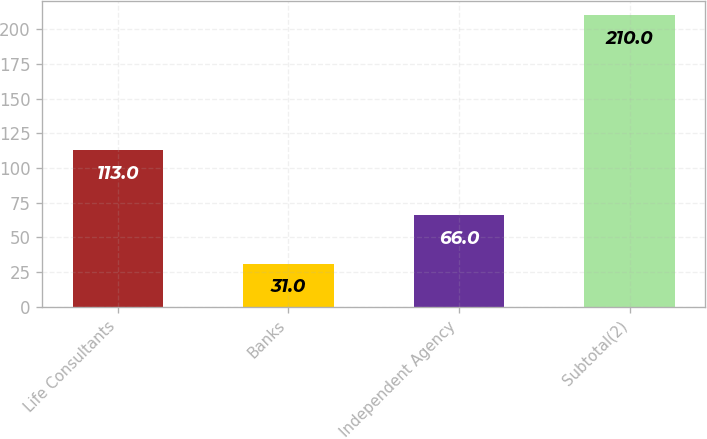<chart> <loc_0><loc_0><loc_500><loc_500><bar_chart><fcel>Life Consultants<fcel>Banks<fcel>Independent Agency<fcel>Subtotal(2)<nl><fcel>113<fcel>31<fcel>66<fcel>210<nl></chart> 